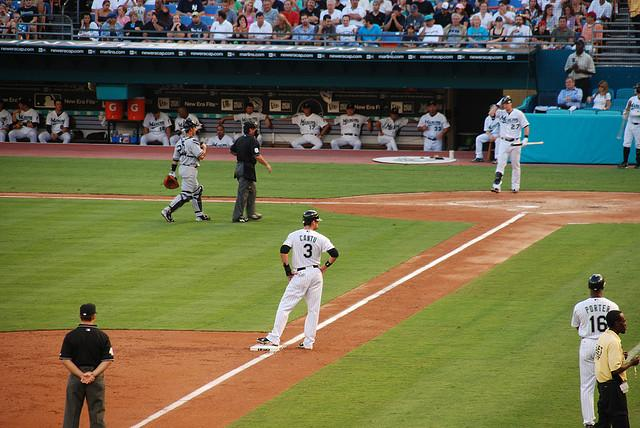What's the area where players are seated on a bench near gatorade coolers? Please explain your reasoning. dugout. That is where the players rest. 